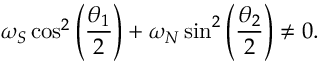<formula> <loc_0><loc_0><loc_500><loc_500>\omega _ { S } \cos ^ { 2 } \left ( \frac { \theta _ { 1 } } { 2 } \right ) + \omega _ { N } \sin ^ { 2 } \left ( \frac { \theta _ { 2 } } { 2 } \right ) \neq 0 .</formula> 